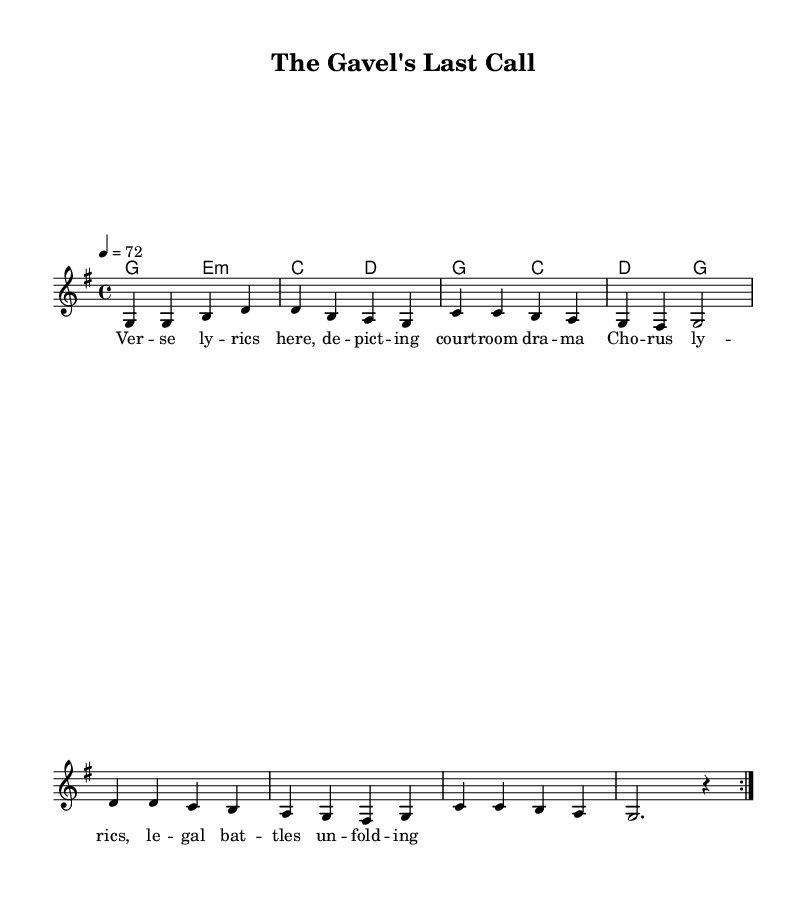What is the key signature of this music? The key signature is G major, which has one sharp (F#). This can be identified by looking at the beginning of the staff where the key signature is indicated.
Answer: G major What is the time signature of this piece? The time signature shown at the beginning is 4/4, which is indicated at the start of the staff. This means there are four beats in a measure, and each quarter note receives one beat.
Answer: 4/4 What is the tempo of the music? The tempo marking shows that the piece is to be played at a speed of 72 beats per minute, indicated by the Spanish term "4 = 72". This tells the performer how fast to play the piece.
Answer: 72 How many times is the verse repeated? The music specifies that the verse is repeated two times, which is indicated by the instruction "\repeat volta 2" before the verse melody.
Answer: 2 What type of legal theme is depicted in the lyrics? The lyrics illustrate courtroom drama and legal battles, as suggested by the placeholder lyrics that mention "court room drama" and "legal battles unfolding." This points to the content's focus on legal themes typical in classic country ballads.
Answer: Courtroom drama What is the chord progression used in the chorus? The chord progression for the chorus consists of G major to C major and then to D major, as indicated in the harmonies section. This provides the harmonic structure that supports the melody during the chorus.
Answer: G to C to D What is the song title? The title is "The Gavel's Last Call," which is provided in the header of the score. This information identifies the piece and suggests its thematic connection to courtroom or legal contexts.
Answer: The Gavel's Last Call 